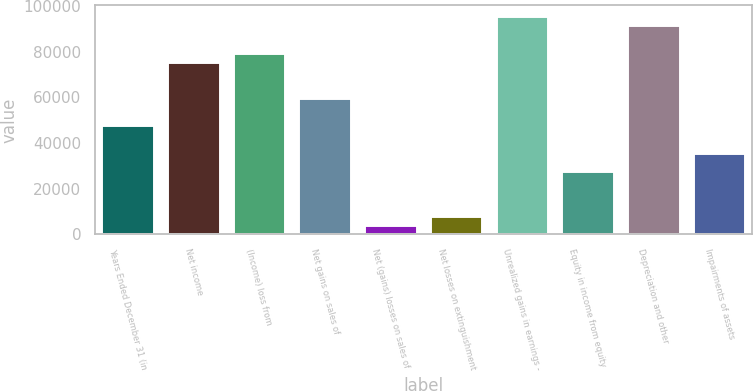<chart> <loc_0><loc_0><loc_500><loc_500><bar_chart><fcel>Years Ended December 31 (in<fcel>Net income<fcel>(Income) loss from<fcel>Net gains on sales of<fcel>Net (gains) losses on sales of<fcel>Net losses on extinguishment<fcel>Unrealized gains in earnings -<fcel>Equity in income from equity<fcel>Depreciation and other<fcel>Impairments of assets<nl><fcel>47781.4<fcel>75653.3<fcel>79635<fcel>59726.5<fcel>3982.7<fcel>7964.4<fcel>95561.8<fcel>27872.9<fcel>91580.1<fcel>35836.3<nl></chart> 